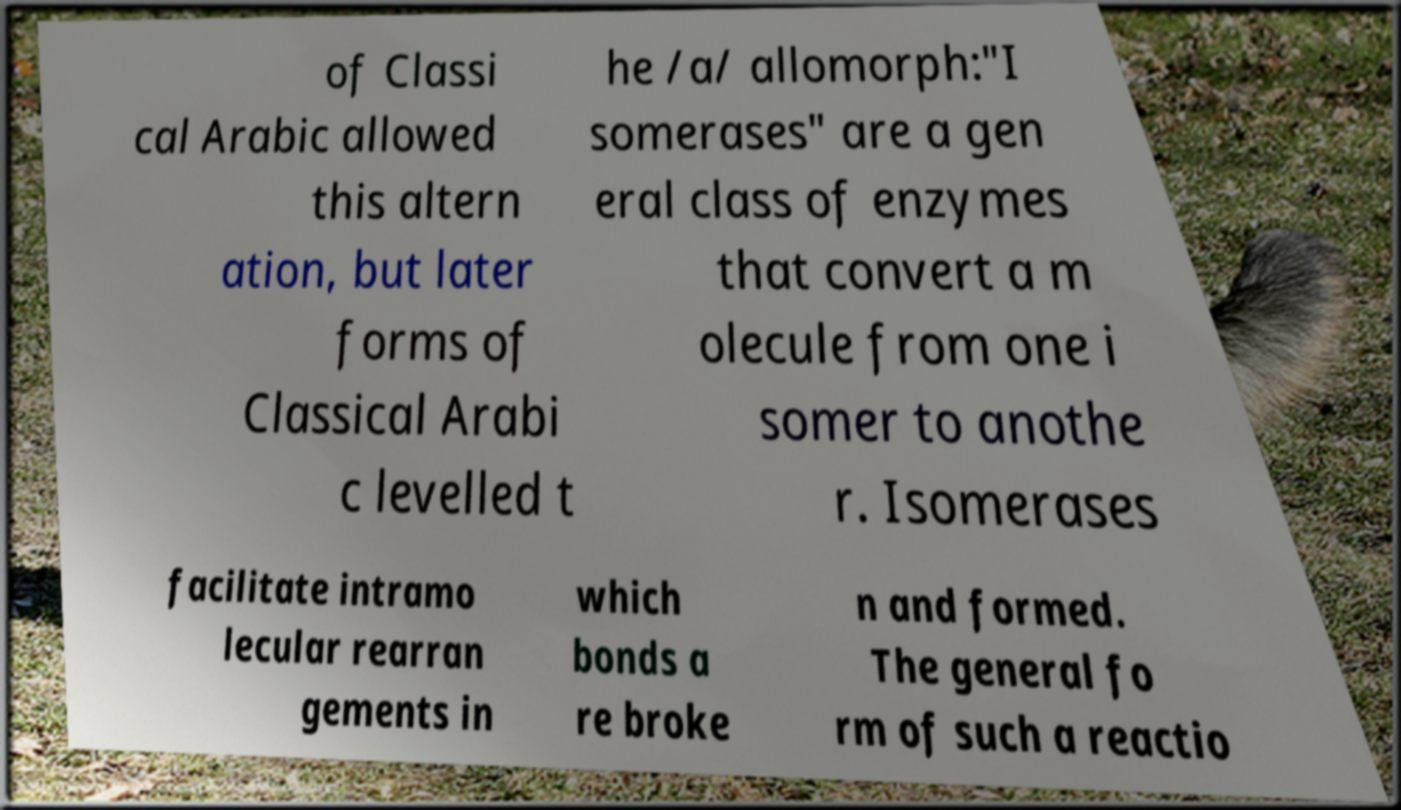Please identify and transcribe the text found in this image. of Classi cal Arabic allowed this altern ation, but later forms of Classical Arabi c levelled t he /a/ allomorph:"I somerases" are a gen eral class of enzymes that convert a m olecule from one i somer to anothe r. Isomerases facilitate intramo lecular rearran gements in which bonds a re broke n and formed. The general fo rm of such a reactio 